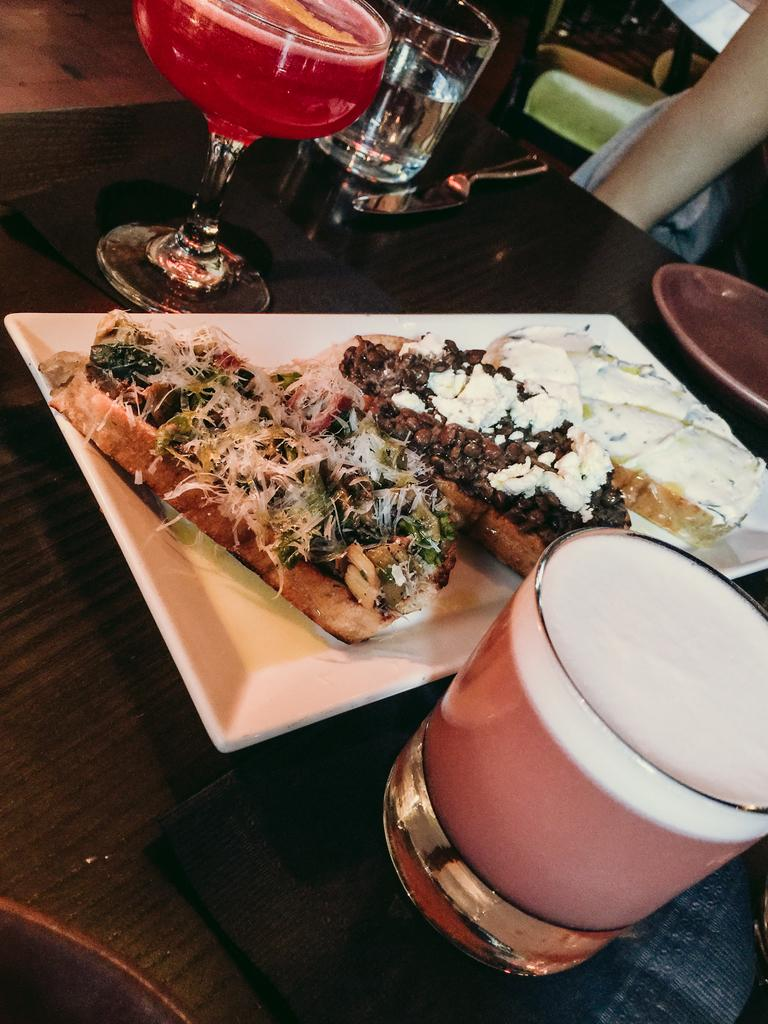What piece of furniture is present in the image? There is a table in the image. What is on the table? There is a serving plate with food and glass tumblers with beverages on the table. What utensil is present on the table? There is a knife on the table. Is there any other type of dishware on the table? Yes, there is an empty plate on the table. What type of chalk is being used to write on the stamp in the image? There is no chalk or stamp present in the image. 